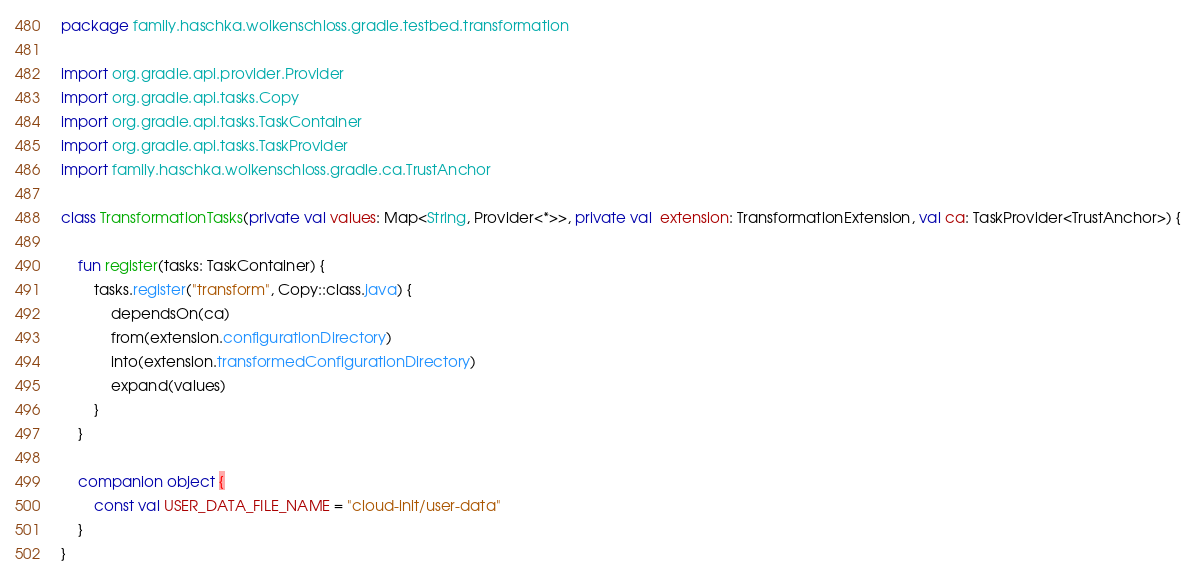Convert code to text. <code><loc_0><loc_0><loc_500><loc_500><_Kotlin_>package family.haschka.wolkenschloss.gradle.testbed.transformation

import org.gradle.api.provider.Provider
import org.gradle.api.tasks.Copy
import org.gradle.api.tasks.TaskContainer
import org.gradle.api.tasks.TaskProvider
import family.haschka.wolkenschloss.gradle.ca.TrustAnchor

class TransformationTasks(private val values: Map<String, Provider<*>>, private val  extension: TransformationExtension, val ca: TaskProvider<TrustAnchor>) {

    fun register(tasks: TaskContainer) {
        tasks.register("transform", Copy::class.java) {
            dependsOn(ca)
            from(extension.configurationDirectory)
            into(extension.transformedConfigurationDirectory)
            expand(values)
        }
    }

    companion object {
        const val USER_DATA_FILE_NAME = "cloud-init/user-data"
    }
}</code> 